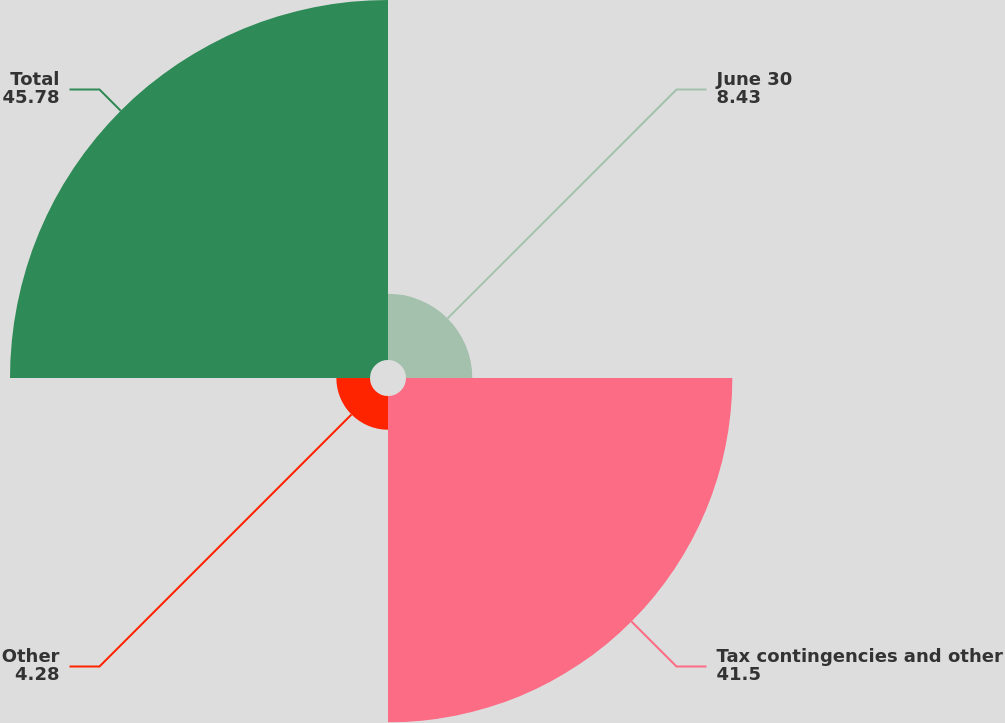<chart> <loc_0><loc_0><loc_500><loc_500><pie_chart><fcel>June 30<fcel>Tax contingencies and other<fcel>Other<fcel>Total<nl><fcel>8.43%<fcel>41.5%<fcel>4.28%<fcel>45.78%<nl></chart> 